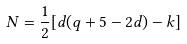Convert formula to latex. <formula><loc_0><loc_0><loc_500><loc_500>N = \frac { 1 } { 2 } [ d ( q + 5 - 2 d ) - k ]</formula> 